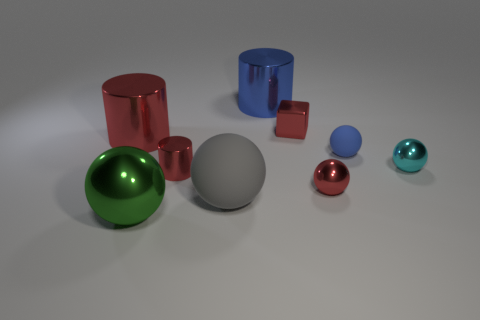What material is the large sphere on the right side of the cylinder in front of the tiny blue matte thing made of?
Provide a short and direct response. Rubber. Is there another ball of the same color as the small rubber ball?
Make the answer very short. No. Do the gray rubber sphere and the ball to the right of the blue rubber sphere have the same size?
Ensure brevity in your answer.  No. There is a rubber thing that is to the right of the small red thing that is behind the blue ball; what number of tiny metal things are on the left side of it?
Ensure brevity in your answer.  3. What number of red objects are left of the tiny metallic cylinder?
Provide a short and direct response. 1. What color is the small object on the left side of the metallic block that is to the right of the big blue cylinder?
Keep it short and to the point. Red. What number of other things are there of the same material as the small cube
Your response must be concise. 6. Are there the same number of big balls that are behind the tiny red metal cylinder and large green metal cylinders?
Ensure brevity in your answer.  Yes. What material is the cylinder that is in front of the tiny cyan shiny thing that is in front of the shiny block behind the big green metal object?
Ensure brevity in your answer.  Metal. There is a matte thing that is on the right side of the gray matte thing; what is its color?
Keep it short and to the point. Blue. 